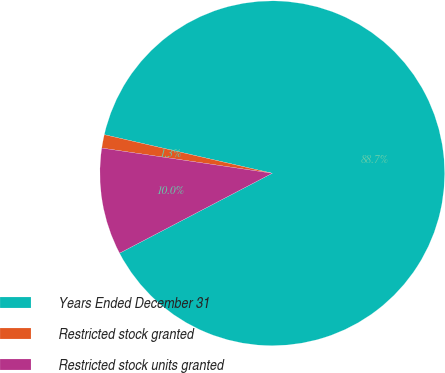Convert chart. <chart><loc_0><loc_0><loc_500><loc_500><pie_chart><fcel>Years Ended December 31<fcel>Restricted stock granted<fcel>Restricted stock units granted<nl><fcel>88.74%<fcel>1.26%<fcel>10.01%<nl></chart> 